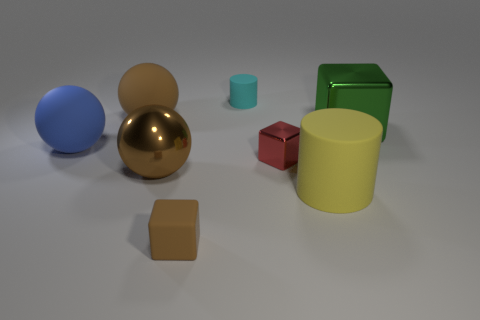What number of large brown objects are there?
Your answer should be compact. 2. There is a metallic cube that is the same size as the cyan matte cylinder; what is its color?
Offer a very short reply. Red. Do the cylinder behind the big cube and the object right of the yellow matte thing have the same material?
Your response must be concise. No. There is a cube to the right of the large thing that is in front of the metallic sphere; how big is it?
Provide a succinct answer. Large. There is a sphere that is in front of the small red metallic object; what is it made of?
Offer a very short reply. Metal. How many things are either big matte spheres that are right of the blue sphere or blocks that are right of the small matte cylinder?
Your answer should be very brief. 3. There is a green thing that is the same shape as the tiny brown matte thing; what is its material?
Provide a succinct answer. Metal. Does the small cube that is in front of the red object have the same color as the shiny object in front of the tiny red thing?
Your answer should be compact. Yes. Is there a blue object that has the same size as the yellow rubber object?
Give a very brief answer. Yes. There is a big sphere that is in front of the green block and behind the metal sphere; what material is it?
Provide a short and direct response. Rubber. 